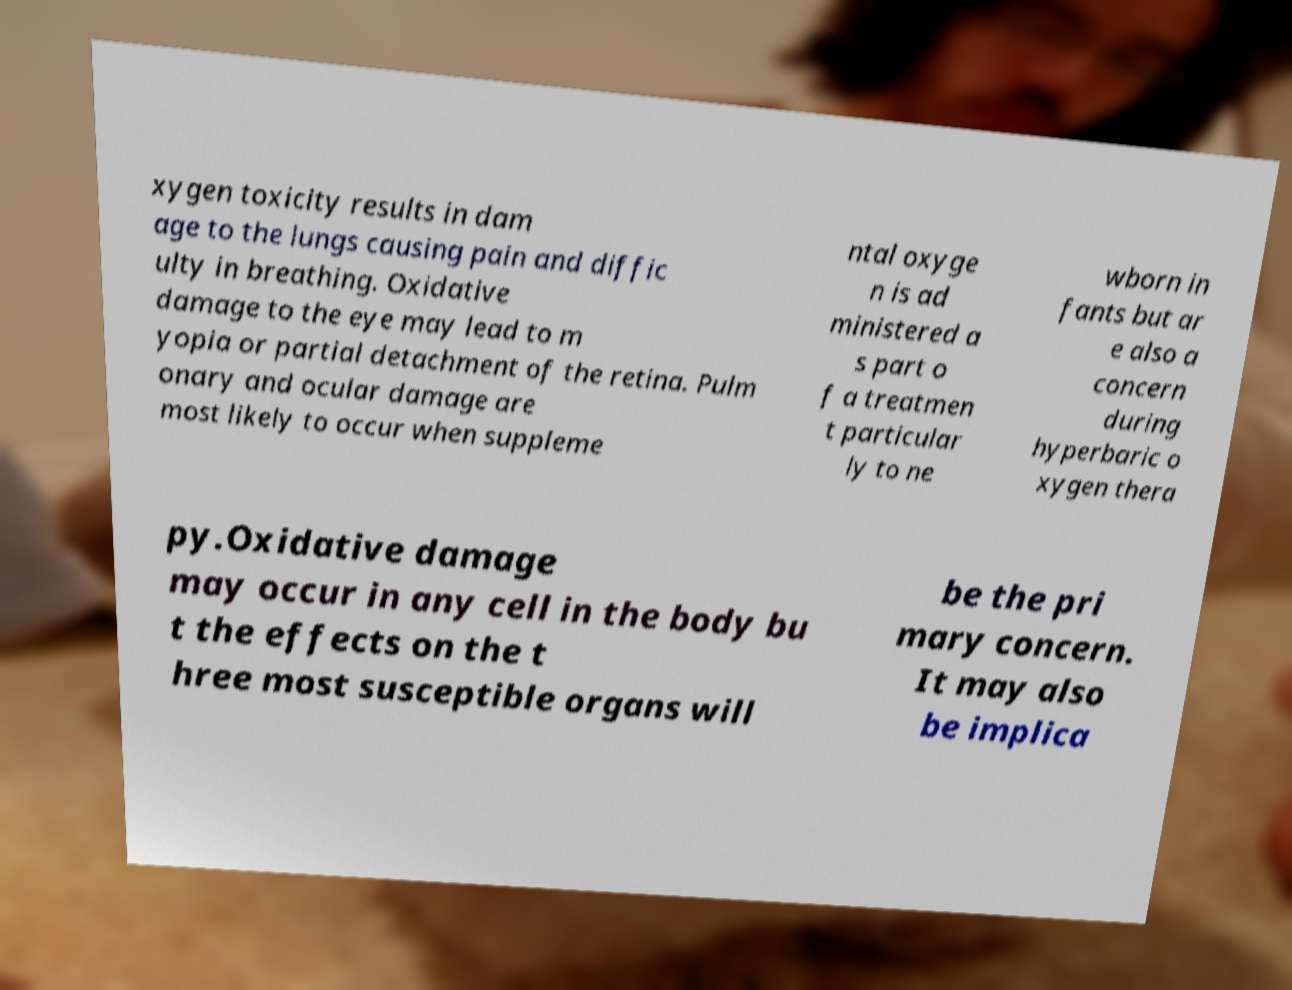For documentation purposes, I need the text within this image transcribed. Could you provide that? xygen toxicity results in dam age to the lungs causing pain and diffic ulty in breathing. Oxidative damage to the eye may lead to m yopia or partial detachment of the retina. Pulm onary and ocular damage are most likely to occur when suppleme ntal oxyge n is ad ministered a s part o f a treatmen t particular ly to ne wborn in fants but ar e also a concern during hyperbaric o xygen thera py.Oxidative damage may occur in any cell in the body bu t the effects on the t hree most susceptible organs will be the pri mary concern. It may also be implica 